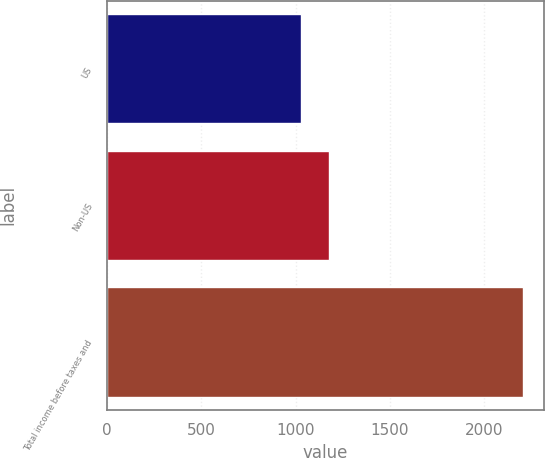Convert chart. <chart><loc_0><loc_0><loc_500><loc_500><bar_chart><fcel>US<fcel>Non-US<fcel>Total income before taxes and<nl><fcel>1030<fcel>1177<fcel>2207<nl></chart> 